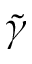<formula> <loc_0><loc_0><loc_500><loc_500>\tilde { \gamma }</formula> 